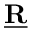Convert formula to latex. <formula><loc_0><loc_0><loc_500><loc_500>\underline { R }</formula> 